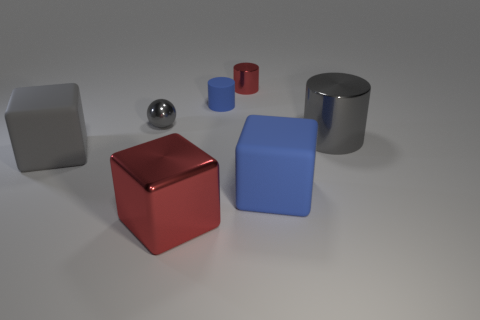Is there a cylinder that is behind the red shiny thing that is in front of the big shiny thing that is behind the blue rubber cube?
Make the answer very short. Yes. How many cubes are either rubber objects or tiny blue matte objects?
Offer a very short reply. 2. Does the tiny blue matte thing have the same shape as the rubber thing that is on the right side of the tiny red cylinder?
Ensure brevity in your answer.  No. Is the number of tiny things in front of the tiny red shiny thing less than the number of tiny brown cylinders?
Make the answer very short. No. There is a small red object; are there any big red blocks in front of it?
Offer a terse response. Yes. Is there a small gray object of the same shape as the small blue object?
Give a very brief answer. No. There is a red object that is the same size as the gray matte thing; what shape is it?
Provide a short and direct response. Cube. What number of things are either gray things that are to the right of the shiny block or large matte cubes?
Offer a very short reply. 3. Is the shiny sphere the same color as the matte cylinder?
Provide a short and direct response. No. What is the size of the cylinder that is on the right side of the small metallic cylinder?
Give a very brief answer. Large. 